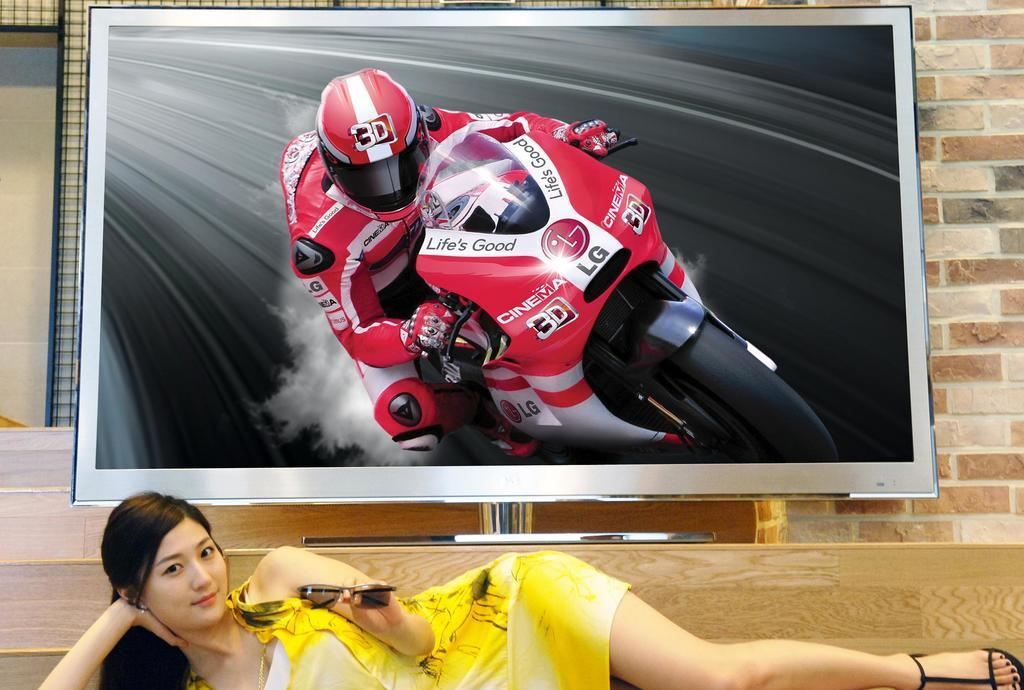What is the position of the woman in the image? The woman is lying on a table in the image. What is located behind the woman? There is a TV screen behind her. What is being displayed on the TV screen? The TV screen is displaying a Moto GP racer. What type of cake is being prepared on the table? There is no cake present in the image; the woman is lying on the table. 